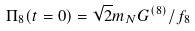Convert formula to latex. <formula><loc_0><loc_0><loc_500><loc_500>\Pi _ { 8 } ( t = 0 ) = \sqrt { 2 } m _ { N } G ^ { ( 8 ) } / f _ { 8 }</formula> 